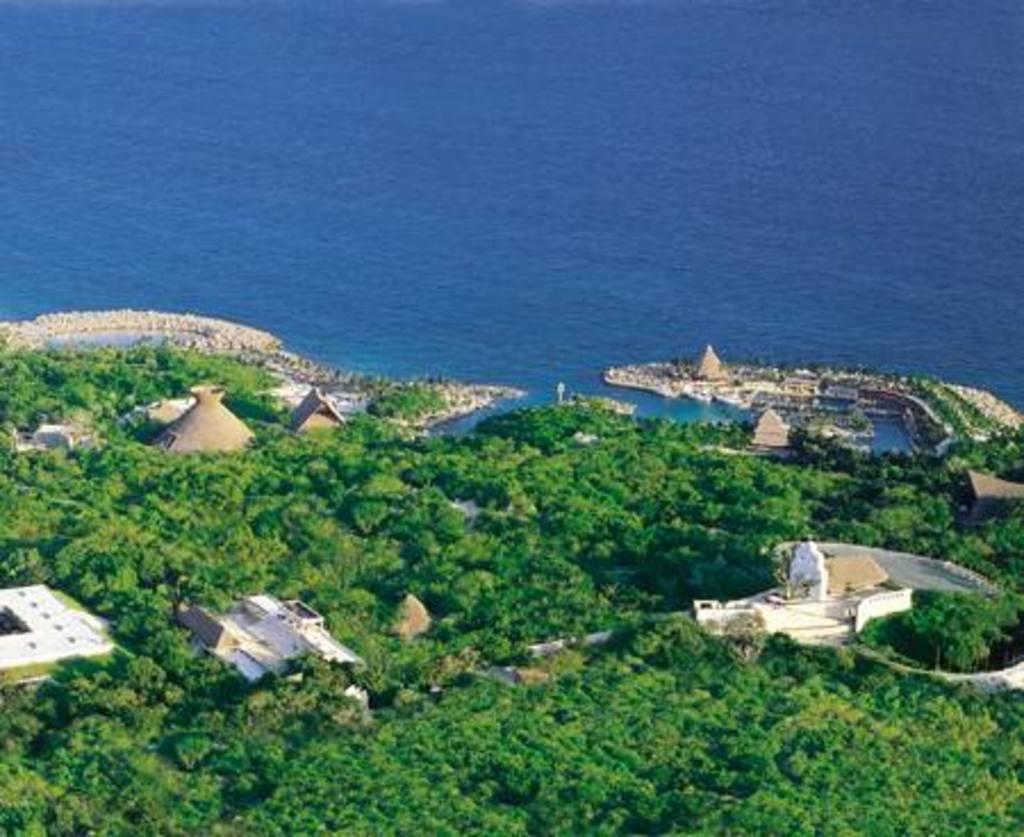Can you describe this image briefly? In this image, we can see trees, houses, walkway and water. 